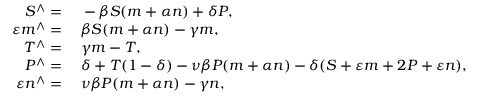<formula> <loc_0><loc_0><loc_500><loc_500>\begin{array} { r l } { S ^ { \wedge } = } & \, - \beta S ( m + \alpha n ) + \delta P , } \\ { \varepsilon m ^ { \wedge } = } & \, \beta S ( m + \alpha n ) - \gamma m , } \\ { T ^ { \wedge } = } & \, \gamma m - T , } \\ { P ^ { \wedge } = } & \, \delta + T ( 1 - \delta ) - \nu \beta P ( m + \alpha n ) - \delta ( S + \varepsilon m + 2 P + \varepsilon n ) , } \\ { \varepsilon n ^ { \wedge } = } & \, \nu \beta P ( m + \alpha n ) - \gamma n , } \end{array}</formula> 